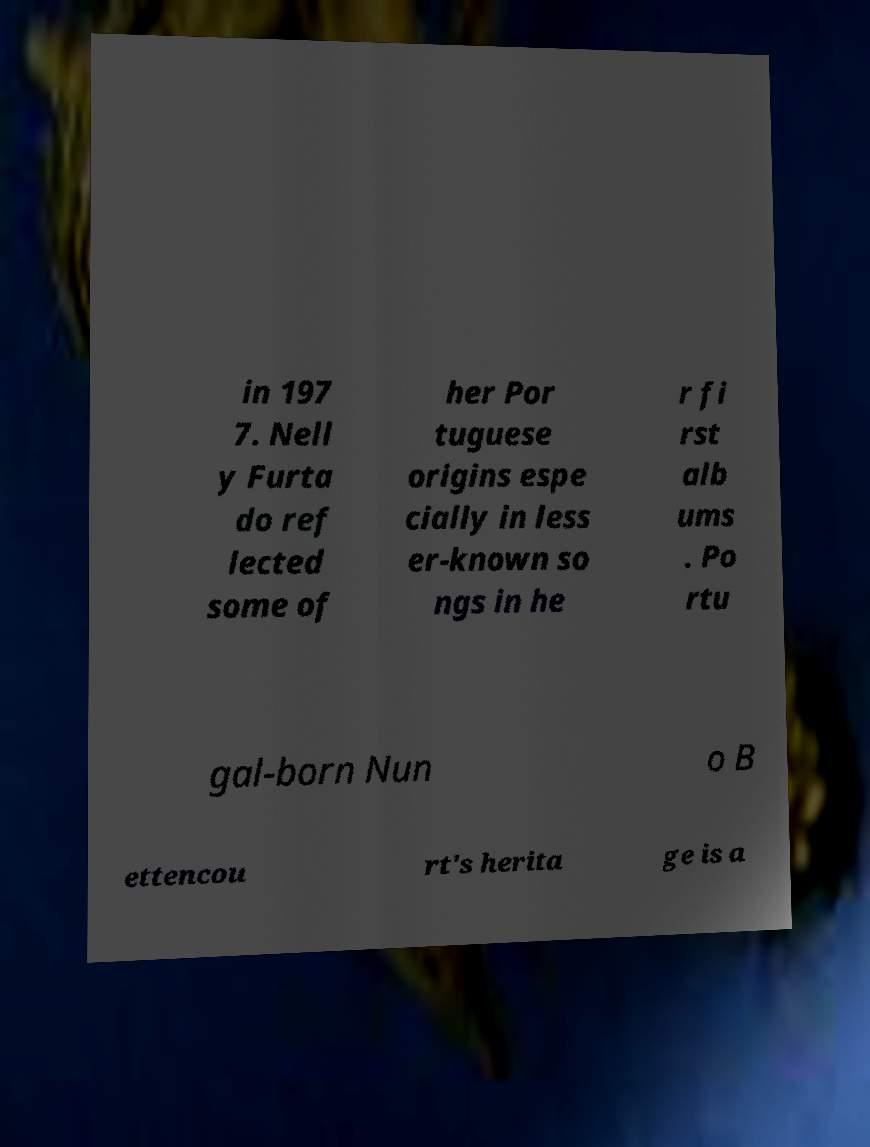Could you extract and type out the text from this image? in 197 7. Nell y Furta do ref lected some of her Por tuguese origins espe cially in less er-known so ngs in he r fi rst alb ums . Po rtu gal-born Nun o B ettencou rt's herita ge is a 